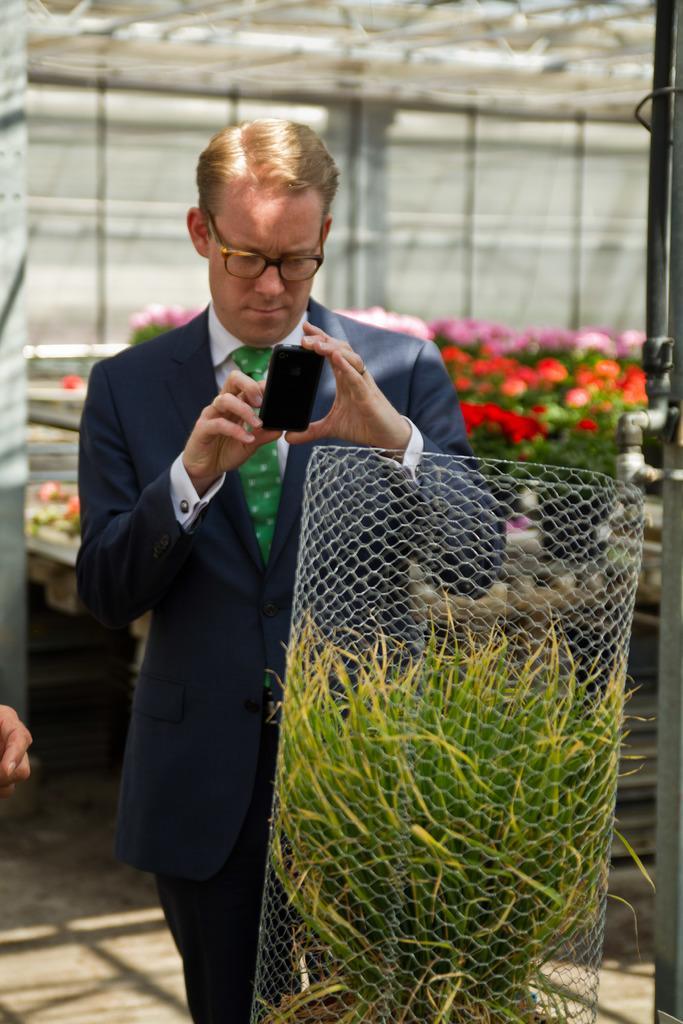Could you give a brief overview of what you see in this image? There is a man standing on the ground. He is wearing a blue blazer and a green tie. He is also wearing spectacles on his face. He is holding a mobile phone with which he is clicking pictures. There is also bushes in front of him. There are flowers behind him in the background. 